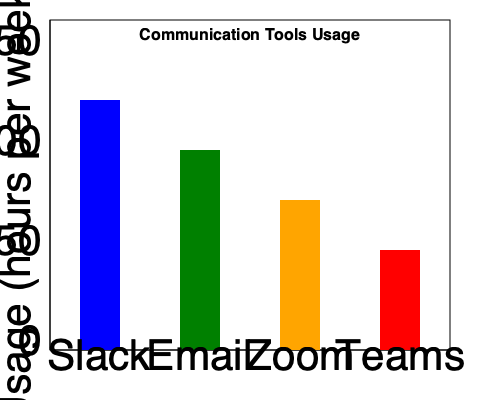As a remote worker handling administrative tasks, you're analyzing the communication tools usage in your company. Based on the bar chart, which tool shows the highest usage, and by how many hours per week does it exceed the second most used tool? To answer this question, we need to follow these steps:

1. Identify the tool with the highest usage:
   - Slack (blue bar): approximately 125 hours
   - Email (green bar): approximately 100 hours
   - Zoom (orange bar): approximately 75 hours
   - Teams (red bar): approximately 50 hours

   Slack has the highest usage at 125 hours per week.

2. Identify the second most used tool:
   Email is the second most used tool at 100 hours per week.

3. Calculate the difference between the highest and second highest:
   $125 - 100 = 25$ hours per week

Therefore, Slack is the most used tool, and it exceeds the usage of Email (the second most used tool) by 25 hours per week.
Answer: Slack; 25 hours 